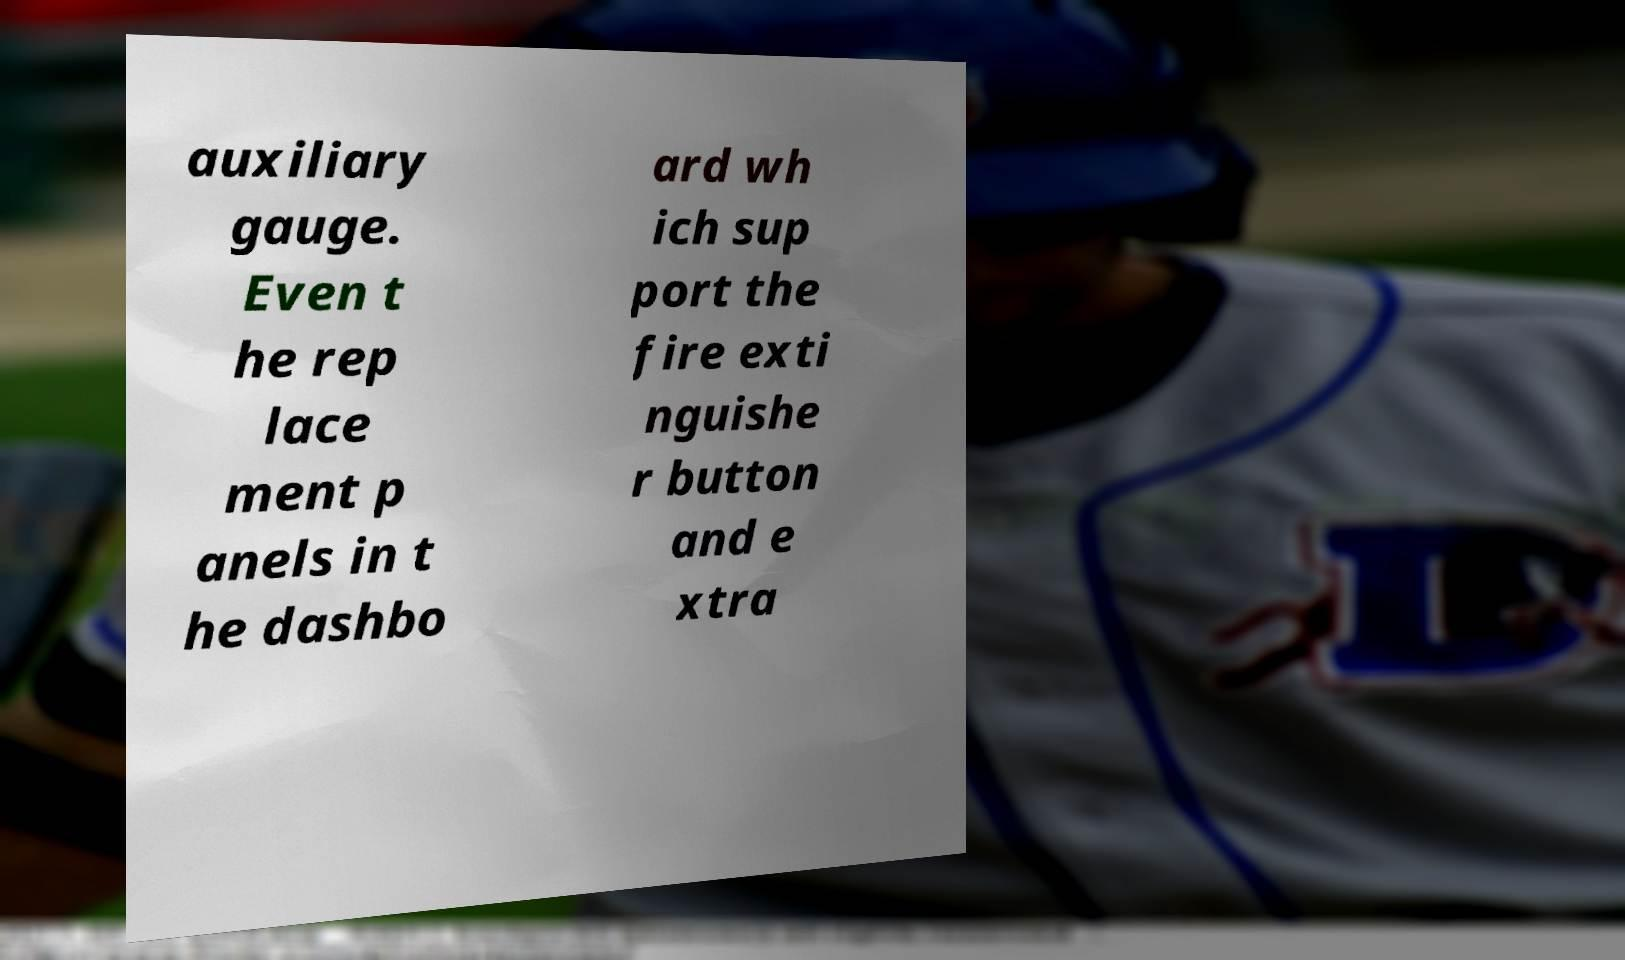Could you extract and type out the text from this image? auxiliary gauge. Even t he rep lace ment p anels in t he dashbo ard wh ich sup port the fire exti nguishe r button and e xtra 